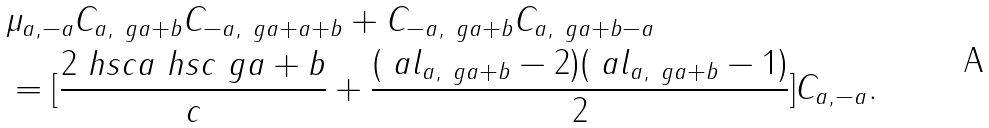Convert formula to latex. <formula><loc_0><loc_0><loc_500><loc_500>& \mu _ { a , - a } C _ { a , \ g a + b } C _ { - a , \ g a + a + b } + C _ { - a , \ g a + b } C _ { a , \ g a + b - a } \\ & = [ \frac { 2 \ h s c { a } \ h s c { \ g a + b } } { c } + \frac { ( \ a l _ { a , \ g a + b } - 2 ) ( \ a l _ { a , \ g a + b } - 1 ) } { 2 } ] C _ { a , - a } .</formula> 